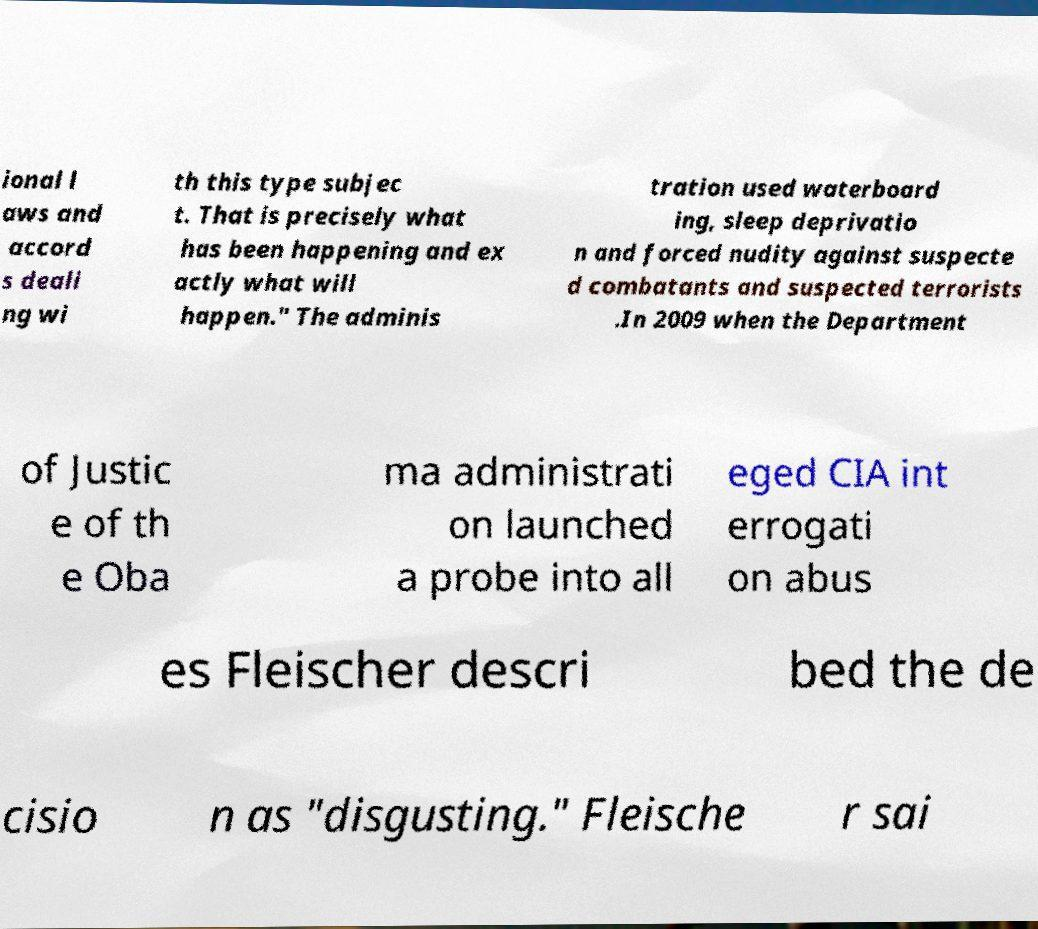Please identify and transcribe the text found in this image. ional l aws and accord s deali ng wi th this type subjec t. That is precisely what has been happening and ex actly what will happen." The adminis tration used waterboard ing, sleep deprivatio n and forced nudity against suspecte d combatants and suspected terrorists .In 2009 when the Department of Justic e of th e Oba ma administrati on launched a probe into all eged CIA int errogati on abus es Fleischer descri bed the de cisio n as "disgusting." Fleische r sai 